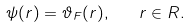Convert formula to latex. <formula><loc_0><loc_0><loc_500><loc_500>\psi ( r ) = \vartheta _ { F } ( r ) , \quad r \in R .</formula> 